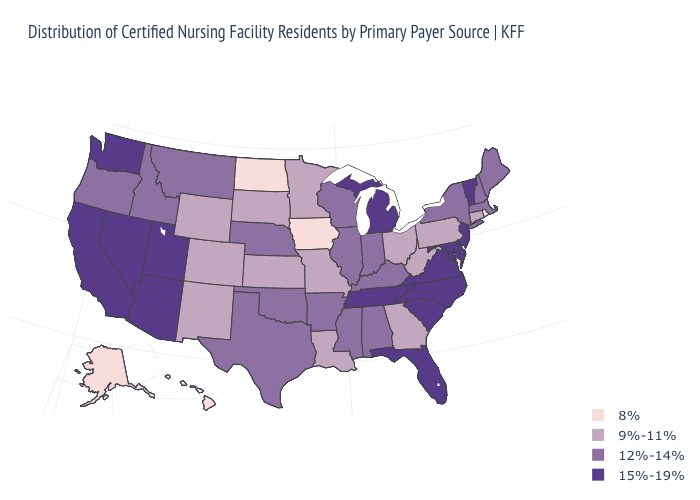Which states have the lowest value in the West?
Be succinct. Alaska, Hawaii. What is the value of Delaware?
Write a very short answer. 15%-19%. What is the highest value in the South ?
Concise answer only. 15%-19%. What is the value of South Carolina?
Short answer required. 15%-19%. Which states hav the highest value in the West?
Answer briefly. Arizona, California, Nevada, Utah, Washington. What is the value of Hawaii?
Be succinct. 8%. Among the states that border Arizona , does New Mexico have the lowest value?
Write a very short answer. Yes. Name the states that have a value in the range 9%-11%?
Quick response, please. Colorado, Connecticut, Georgia, Kansas, Louisiana, Minnesota, Missouri, New Mexico, Ohio, Pennsylvania, South Dakota, West Virginia, Wyoming. Which states have the lowest value in the USA?
Be succinct. Alaska, Hawaii, Iowa, North Dakota, Rhode Island. Name the states that have a value in the range 15%-19%?
Keep it brief. Arizona, California, Delaware, Florida, Maryland, Michigan, Nevada, New Jersey, North Carolina, South Carolina, Tennessee, Utah, Vermont, Virginia, Washington. Does Wyoming have the same value as Minnesota?
Give a very brief answer. Yes. What is the highest value in the USA?
Concise answer only. 15%-19%. Among the states that border Maryland , does Delaware have the lowest value?
Give a very brief answer. No. Name the states that have a value in the range 9%-11%?
Short answer required. Colorado, Connecticut, Georgia, Kansas, Louisiana, Minnesota, Missouri, New Mexico, Ohio, Pennsylvania, South Dakota, West Virginia, Wyoming. 